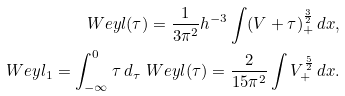<formula> <loc_0><loc_0><loc_500><loc_500>\ W e y l ( \tau ) = \frac { 1 } { 3 \pi ^ { 2 } } h ^ { - 3 } \int ( V + \tau ) _ { + } ^ { \frac { 3 } { 2 } } \, d x , \\ \ W e y l _ { 1 } = \int _ { - \infty } ^ { 0 } \tau \, d _ { \tau } \ W e y l ( \tau ) = \frac { 2 } { 1 5 \pi ^ { 2 } } \int V _ { + } ^ { \frac { 5 } { 2 } } \, d x .</formula> 